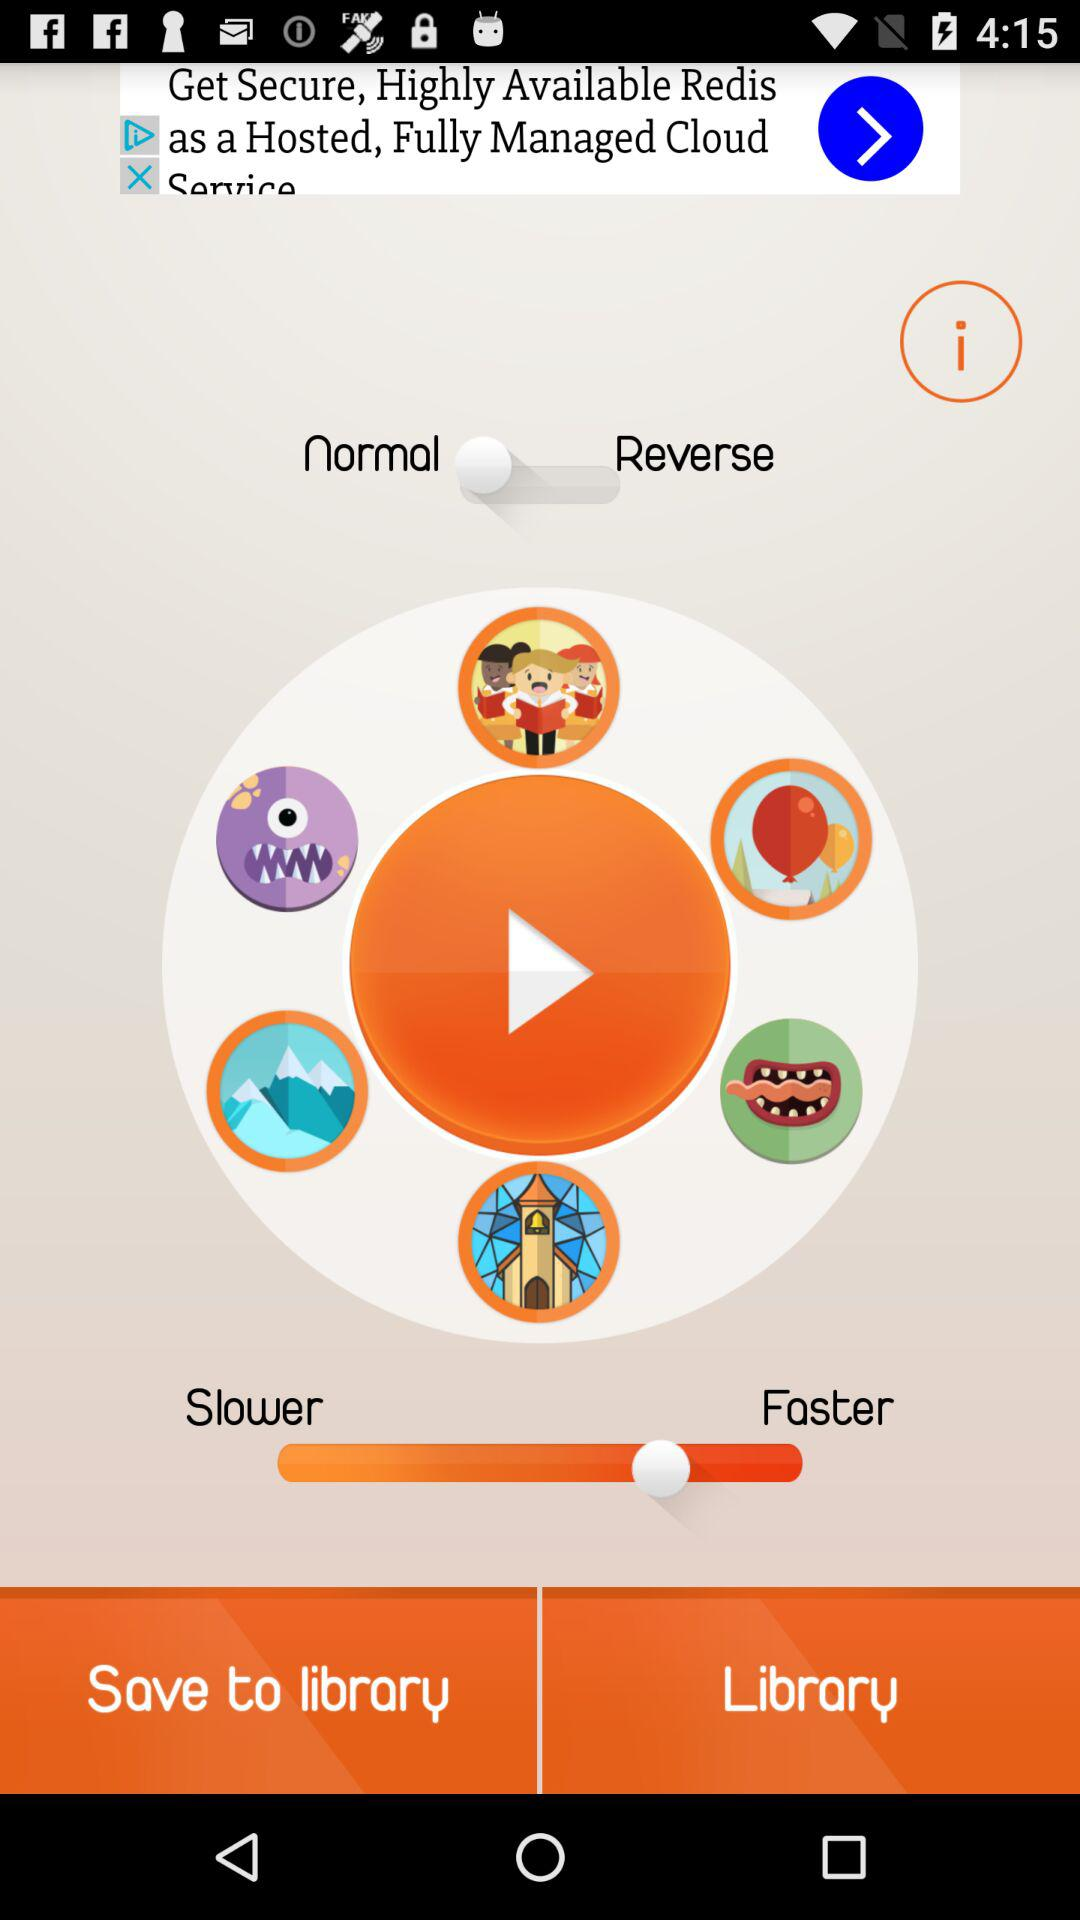Which items are saved to the library?
When the provided information is insufficient, respond with <no answer>. <no answer> 